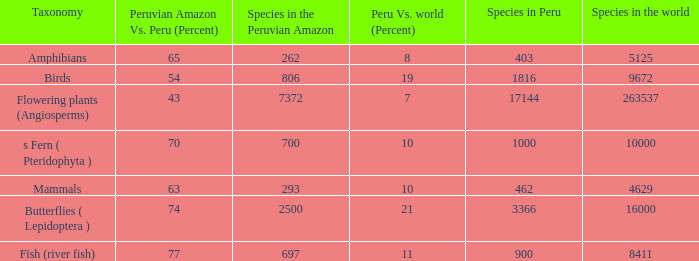What's the minimum species in the peruvian amazon with species in peru of 1000 700.0. Would you mind parsing the complete table? {'header': ['Taxonomy', 'Peruvian Amazon Vs. Peru (Percent)', 'Species in the Peruvian Amazon', 'Peru Vs. world (Percent)', 'Species in Peru', 'Species in the world'], 'rows': [['Amphibians', '65', '262', '8', '403', '5125'], ['Birds', '54', '806', '19', '1816', '9672'], ['Flowering plants (Angiosperms)', '43', '7372', '7', '17144', '263537'], ['s Fern ( Pteridophyta )', '70', '700', '10', '1000', '10000'], ['Mammals', '63', '293', '10', '462', '4629'], ['Butterflies ( Lepidoptera )', '74', '2500', '21', '3366', '16000'], ['Fish (river fish)', '77', '697', '11', '900', '8411']]} 